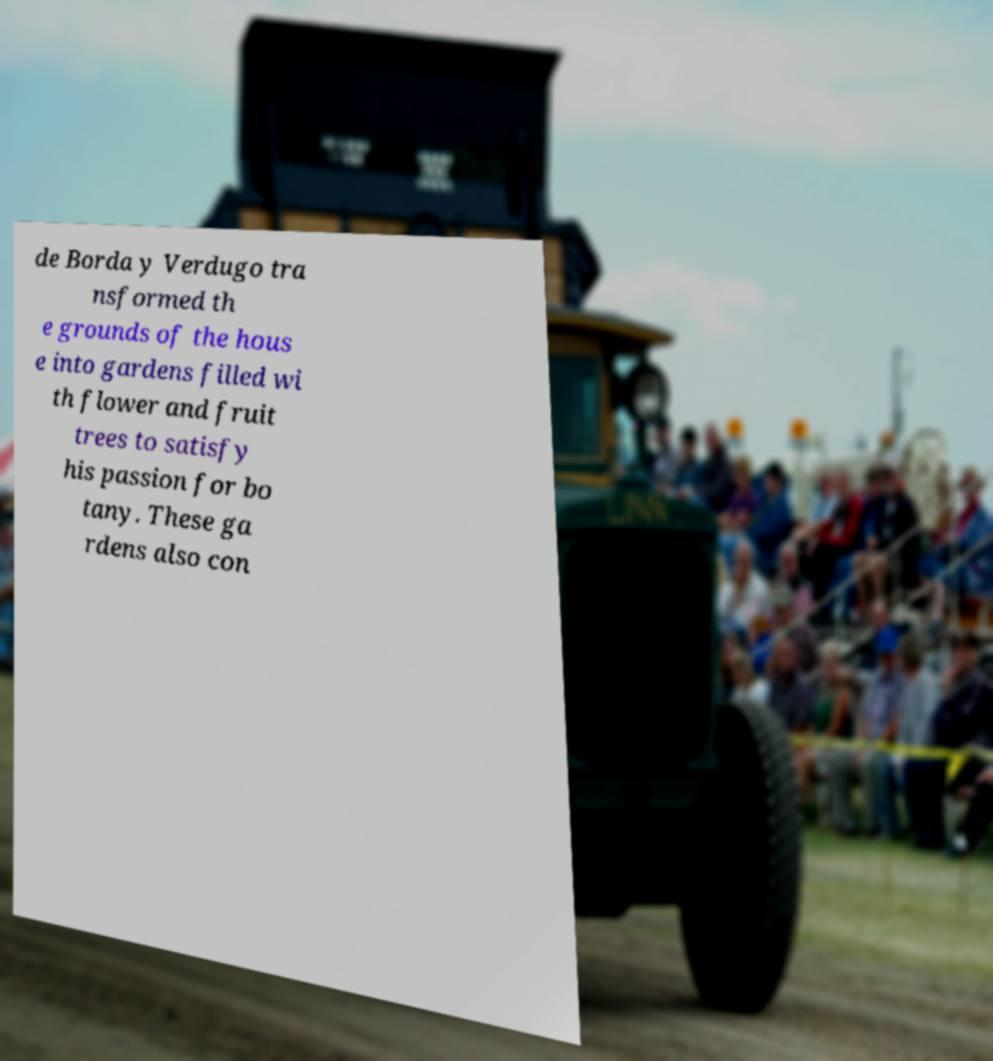Could you assist in decoding the text presented in this image and type it out clearly? de Borda y Verdugo tra nsformed th e grounds of the hous e into gardens filled wi th flower and fruit trees to satisfy his passion for bo tany. These ga rdens also con 